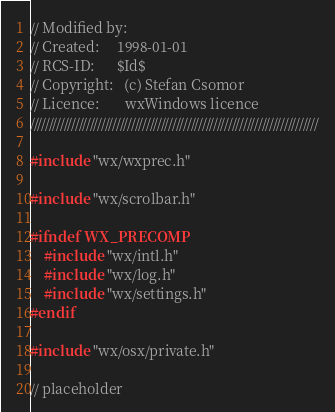Convert code to text. <code><loc_0><loc_0><loc_500><loc_500><_ObjectiveC_>// Modified by:
// Created:     1998-01-01
// RCS-ID:      $Id$
// Copyright:   (c) Stefan Csomor
// Licence:       wxWindows licence
/////////////////////////////////////////////////////////////////////////////

#include "wx/wxprec.h"

#include "wx/scrolbar.h"

#ifndef WX_PRECOMP
    #include "wx/intl.h"
    #include "wx/log.h"
    #include "wx/settings.h"
#endif

#include "wx/osx/private.h"

// placeholder</code> 